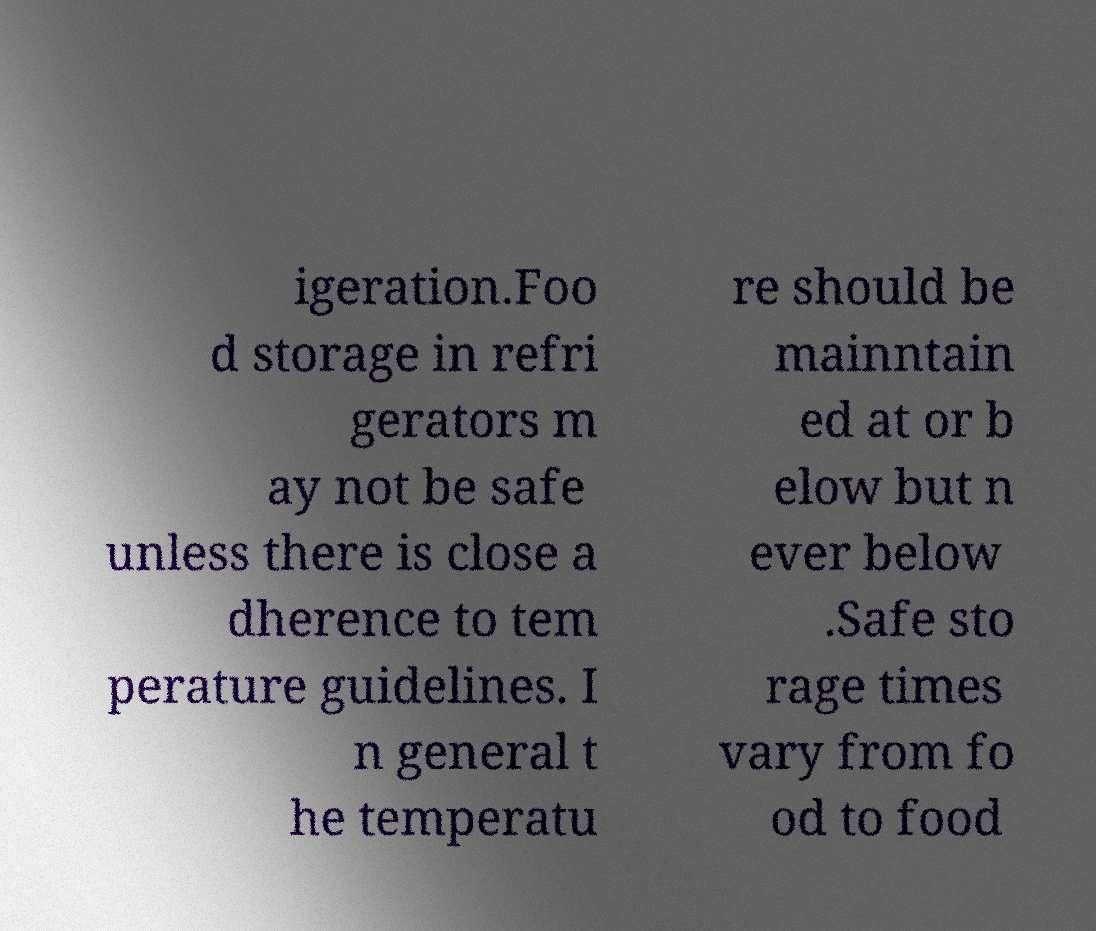Can you accurately transcribe the text from the provided image for me? igeration.Foo d storage in refri gerators m ay not be safe unless there is close a dherence to tem perature guidelines. I n general t he temperatu re should be mainntain ed at or b elow but n ever below .Safe sto rage times vary from fo od to food 